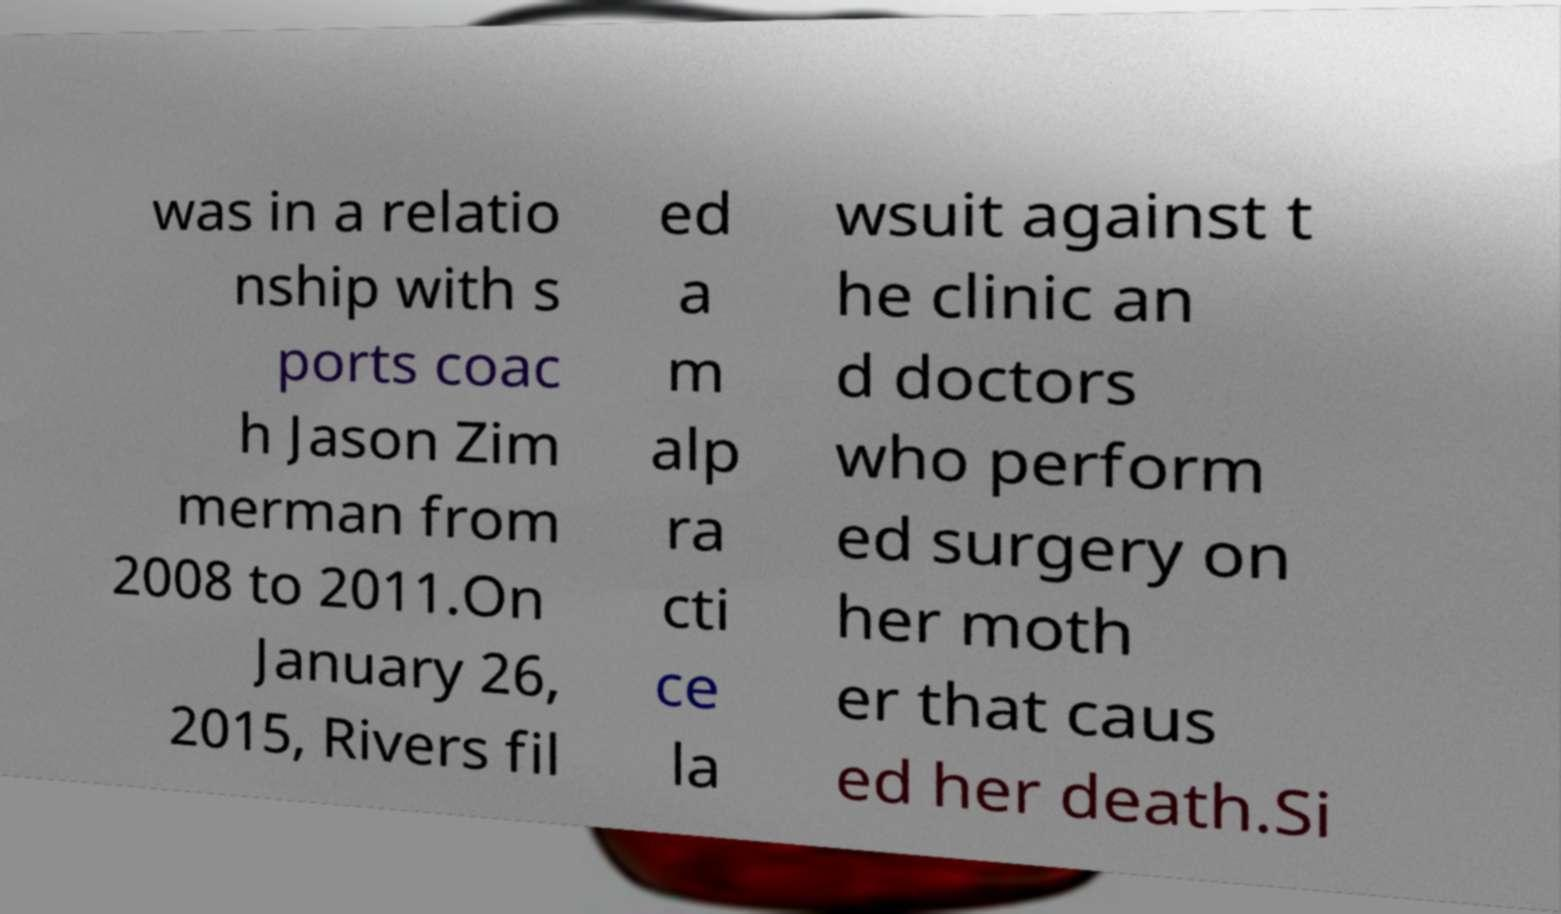What messages or text are displayed in this image? I need them in a readable, typed format. was in a relatio nship with s ports coac h Jason Zim merman from 2008 to 2011.On January 26, 2015, Rivers fil ed a m alp ra cti ce la wsuit against t he clinic an d doctors who perform ed surgery on her moth er that caus ed her death.Si 